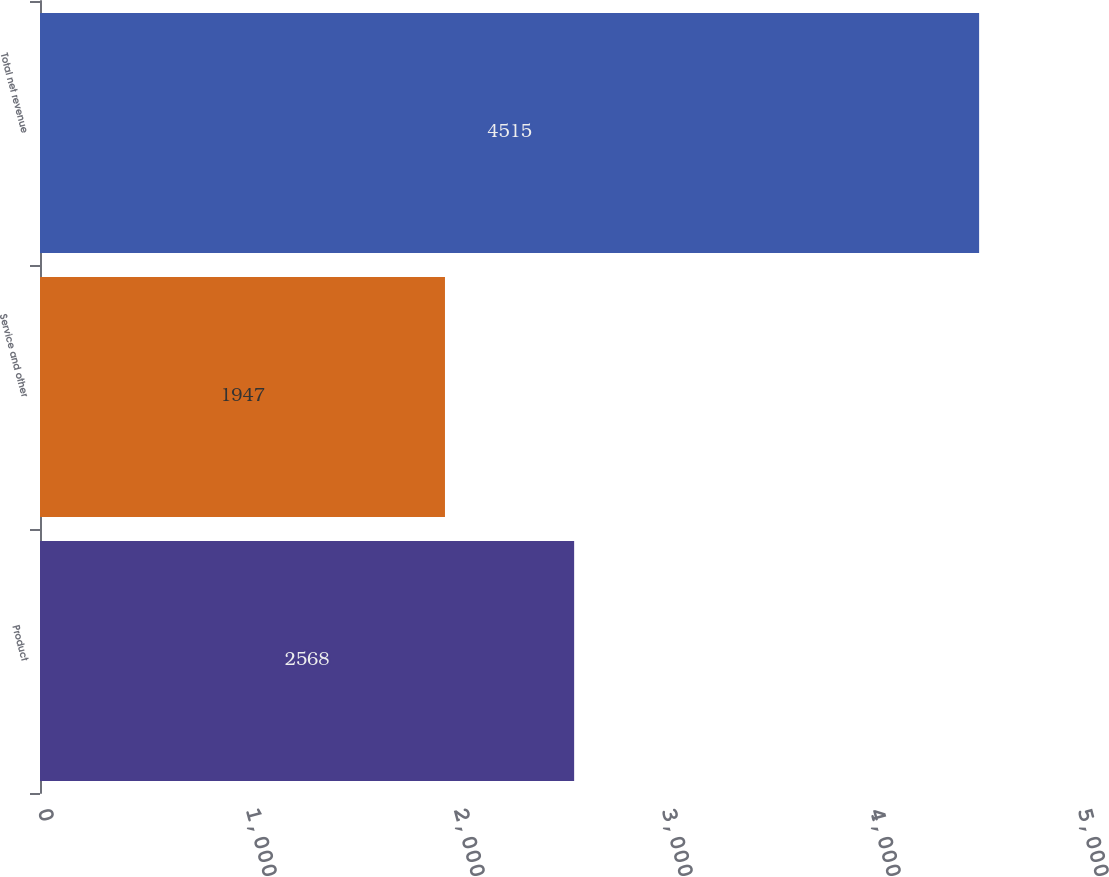Convert chart to OTSL. <chart><loc_0><loc_0><loc_500><loc_500><bar_chart><fcel>Product<fcel>Service and other<fcel>Total net revenue<nl><fcel>2568<fcel>1947<fcel>4515<nl></chart> 